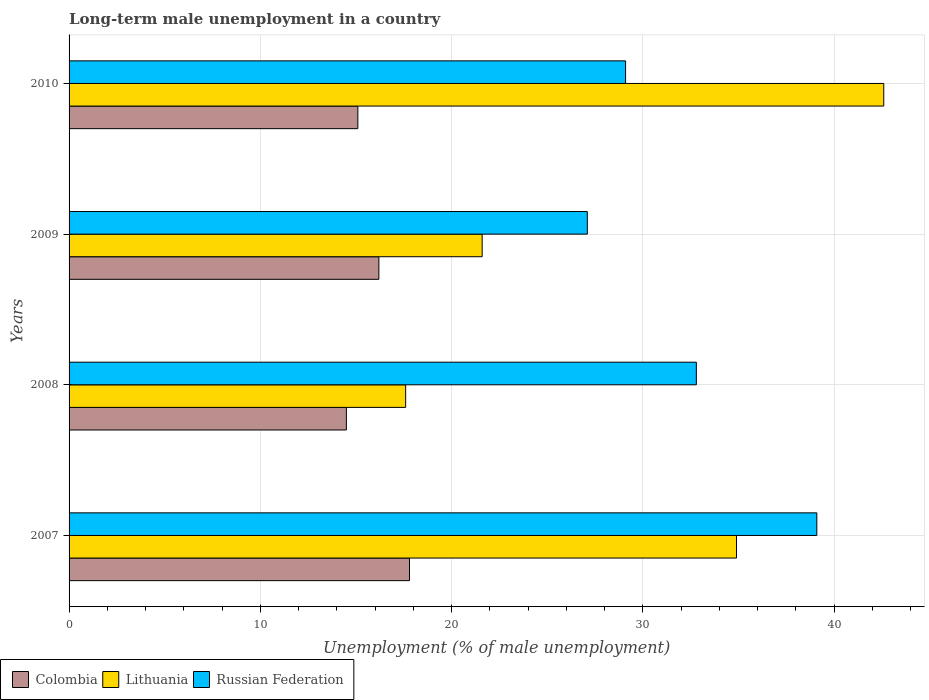How many groups of bars are there?
Offer a terse response. 4. Are the number of bars per tick equal to the number of legend labels?
Your response must be concise. Yes. What is the label of the 1st group of bars from the top?
Your answer should be compact. 2010. In how many cases, is the number of bars for a given year not equal to the number of legend labels?
Your answer should be compact. 0. What is the percentage of long-term unemployed male population in Colombia in 2007?
Offer a terse response. 17.8. Across all years, what is the maximum percentage of long-term unemployed male population in Russian Federation?
Keep it short and to the point. 39.1. What is the total percentage of long-term unemployed male population in Russian Federation in the graph?
Make the answer very short. 128.1. What is the difference between the percentage of long-term unemployed male population in Colombia in 2007 and that in 2010?
Ensure brevity in your answer.  2.7. What is the difference between the percentage of long-term unemployed male population in Lithuania in 2010 and the percentage of long-term unemployed male population in Russian Federation in 2009?
Your answer should be compact. 15.5. What is the average percentage of long-term unemployed male population in Colombia per year?
Ensure brevity in your answer.  15.9. In the year 2008, what is the difference between the percentage of long-term unemployed male population in Colombia and percentage of long-term unemployed male population in Lithuania?
Offer a terse response. -3.1. In how many years, is the percentage of long-term unemployed male population in Colombia greater than 42 %?
Your answer should be compact. 0. What is the ratio of the percentage of long-term unemployed male population in Colombia in 2007 to that in 2008?
Provide a short and direct response. 1.23. Is the percentage of long-term unemployed male population in Lithuania in 2007 less than that in 2010?
Your answer should be very brief. Yes. What is the difference between the highest and the second highest percentage of long-term unemployed male population in Russian Federation?
Your answer should be compact. 6.3. What is the difference between the highest and the lowest percentage of long-term unemployed male population in Lithuania?
Ensure brevity in your answer.  25. What does the 1st bar from the top in 2008 represents?
Give a very brief answer. Russian Federation. What does the 2nd bar from the bottom in 2008 represents?
Ensure brevity in your answer.  Lithuania. Is it the case that in every year, the sum of the percentage of long-term unemployed male population in Russian Federation and percentage of long-term unemployed male population in Lithuania is greater than the percentage of long-term unemployed male population in Colombia?
Ensure brevity in your answer.  Yes. How many bars are there?
Provide a succinct answer. 12. Are all the bars in the graph horizontal?
Give a very brief answer. Yes. How many years are there in the graph?
Your response must be concise. 4. What is the difference between two consecutive major ticks on the X-axis?
Make the answer very short. 10. Does the graph contain any zero values?
Offer a terse response. No. Where does the legend appear in the graph?
Your response must be concise. Bottom left. What is the title of the graph?
Keep it short and to the point. Long-term male unemployment in a country. Does "Fiji" appear as one of the legend labels in the graph?
Your response must be concise. No. What is the label or title of the X-axis?
Your answer should be compact. Unemployment (% of male unemployment). What is the Unemployment (% of male unemployment) in Colombia in 2007?
Make the answer very short. 17.8. What is the Unemployment (% of male unemployment) of Lithuania in 2007?
Provide a succinct answer. 34.9. What is the Unemployment (% of male unemployment) of Russian Federation in 2007?
Keep it short and to the point. 39.1. What is the Unemployment (% of male unemployment) in Lithuania in 2008?
Provide a succinct answer. 17.6. What is the Unemployment (% of male unemployment) of Russian Federation in 2008?
Keep it short and to the point. 32.8. What is the Unemployment (% of male unemployment) in Colombia in 2009?
Make the answer very short. 16.2. What is the Unemployment (% of male unemployment) in Lithuania in 2009?
Keep it short and to the point. 21.6. What is the Unemployment (% of male unemployment) in Russian Federation in 2009?
Provide a succinct answer. 27.1. What is the Unemployment (% of male unemployment) of Colombia in 2010?
Your response must be concise. 15.1. What is the Unemployment (% of male unemployment) of Lithuania in 2010?
Give a very brief answer. 42.6. What is the Unemployment (% of male unemployment) in Russian Federation in 2010?
Keep it short and to the point. 29.1. Across all years, what is the maximum Unemployment (% of male unemployment) in Colombia?
Keep it short and to the point. 17.8. Across all years, what is the maximum Unemployment (% of male unemployment) in Lithuania?
Offer a very short reply. 42.6. Across all years, what is the maximum Unemployment (% of male unemployment) of Russian Federation?
Offer a very short reply. 39.1. Across all years, what is the minimum Unemployment (% of male unemployment) of Lithuania?
Offer a very short reply. 17.6. Across all years, what is the minimum Unemployment (% of male unemployment) in Russian Federation?
Provide a succinct answer. 27.1. What is the total Unemployment (% of male unemployment) in Colombia in the graph?
Offer a very short reply. 63.6. What is the total Unemployment (% of male unemployment) of Lithuania in the graph?
Make the answer very short. 116.7. What is the total Unemployment (% of male unemployment) in Russian Federation in the graph?
Your answer should be compact. 128.1. What is the difference between the Unemployment (% of male unemployment) in Lithuania in 2007 and that in 2008?
Give a very brief answer. 17.3. What is the difference between the Unemployment (% of male unemployment) of Russian Federation in 2007 and that in 2008?
Provide a succinct answer. 6.3. What is the difference between the Unemployment (% of male unemployment) in Colombia in 2007 and that in 2009?
Offer a terse response. 1.6. What is the difference between the Unemployment (% of male unemployment) of Colombia in 2008 and that in 2010?
Ensure brevity in your answer.  -0.6. What is the difference between the Unemployment (% of male unemployment) of Colombia in 2009 and that in 2010?
Offer a very short reply. 1.1. What is the difference between the Unemployment (% of male unemployment) in Russian Federation in 2009 and that in 2010?
Offer a terse response. -2. What is the difference between the Unemployment (% of male unemployment) in Colombia in 2007 and the Unemployment (% of male unemployment) in Russian Federation in 2009?
Offer a terse response. -9.3. What is the difference between the Unemployment (% of male unemployment) in Lithuania in 2007 and the Unemployment (% of male unemployment) in Russian Federation in 2009?
Provide a succinct answer. 7.8. What is the difference between the Unemployment (% of male unemployment) of Colombia in 2007 and the Unemployment (% of male unemployment) of Lithuania in 2010?
Your response must be concise. -24.8. What is the difference between the Unemployment (% of male unemployment) in Colombia in 2007 and the Unemployment (% of male unemployment) in Russian Federation in 2010?
Your answer should be compact. -11.3. What is the difference between the Unemployment (% of male unemployment) in Lithuania in 2007 and the Unemployment (% of male unemployment) in Russian Federation in 2010?
Keep it short and to the point. 5.8. What is the difference between the Unemployment (% of male unemployment) of Colombia in 2008 and the Unemployment (% of male unemployment) of Lithuania in 2009?
Offer a terse response. -7.1. What is the difference between the Unemployment (% of male unemployment) in Colombia in 2008 and the Unemployment (% of male unemployment) in Russian Federation in 2009?
Offer a very short reply. -12.6. What is the difference between the Unemployment (% of male unemployment) in Colombia in 2008 and the Unemployment (% of male unemployment) in Lithuania in 2010?
Your answer should be compact. -28.1. What is the difference between the Unemployment (% of male unemployment) of Colombia in 2008 and the Unemployment (% of male unemployment) of Russian Federation in 2010?
Keep it short and to the point. -14.6. What is the difference between the Unemployment (% of male unemployment) in Lithuania in 2008 and the Unemployment (% of male unemployment) in Russian Federation in 2010?
Your answer should be compact. -11.5. What is the difference between the Unemployment (% of male unemployment) of Colombia in 2009 and the Unemployment (% of male unemployment) of Lithuania in 2010?
Ensure brevity in your answer.  -26.4. What is the difference between the Unemployment (% of male unemployment) of Lithuania in 2009 and the Unemployment (% of male unemployment) of Russian Federation in 2010?
Give a very brief answer. -7.5. What is the average Unemployment (% of male unemployment) in Lithuania per year?
Offer a very short reply. 29.18. What is the average Unemployment (% of male unemployment) in Russian Federation per year?
Ensure brevity in your answer.  32.02. In the year 2007, what is the difference between the Unemployment (% of male unemployment) of Colombia and Unemployment (% of male unemployment) of Lithuania?
Your answer should be compact. -17.1. In the year 2007, what is the difference between the Unemployment (% of male unemployment) in Colombia and Unemployment (% of male unemployment) in Russian Federation?
Your answer should be very brief. -21.3. In the year 2007, what is the difference between the Unemployment (% of male unemployment) of Lithuania and Unemployment (% of male unemployment) of Russian Federation?
Provide a short and direct response. -4.2. In the year 2008, what is the difference between the Unemployment (% of male unemployment) in Colombia and Unemployment (% of male unemployment) in Russian Federation?
Provide a succinct answer. -18.3. In the year 2008, what is the difference between the Unemployment (% of male unemployment) in Lithuania and Unemployment (% of male unemployment) in Russian Federation?
Your answer should be very brief. -15.2. In the year 2009, what is the difference between the Unemployment (% of male unemployment) of Colombia and Unemployment (% of male unemployment) of Lithuania?
Your answer should be very brief. -5.4. In the year 2009, what is the difference between the Unemployment (% of male unemployment) in Colombia and Unemployment (% of male unemployment) in Russian Federation?
Make the answer very short. -10.9. In the year 2009, what is the difference between the Unemployment (% of male unemployment) of Lithuania and Unemployment (% of male unemployment) of Russian Federation?
Ensure brevity in your answer.  -5.5. In the year 2010, what is the difference between the Unemployment (% of male unemployment) in Colombia and Unemployment (% of male unemployment) in Lithuania?
Your answer should be compact. -27.5. What is the ratio of the Unemployment (% of male unemployment) of Colombia in 2007 to that in 2008?
Ensure brevity in your answer.  1.23. What is the ratio of the Unemployment (% of male unemployment) in Lithuania in 2007 to that in 2008?
Your response must be concise. 1.98. What is the ratio of the Unemployment (% of male unemployment) in Russian Federation in 2007 to that in 2008?
Provide a succinct answer. 1.19. What is the ratio of the Unemployment (% of male unemployment) of Colombia in 2007 to that in 2009?
Give a very brief answer. 1.1. What is the ratio of the Unemployment (% of male unemployment) in Lithuania in 2007 to that in 2009?
Offer a very short reply. 1.62. What is the ratio of the Unemployment (% of male unemployment) in Russian Federation in 2007 to that in 2009?
Provide a succinct answer. 1.44. What is the ratio of the Unemployment (% of male unemployment) of Colombia in 2007 to that in 2010?
Provide a succinct answer. 1.18. What is the ratio of the Unemployment (% of male unemployment) of Lithuania in 2007 to that in 2010?
Make the answer very short. 0.82. What is the ratio of the Unemployment (% of male unemployment) of Russian Federation in 2007 to that in 2010?
Keep it short and to the point. 1.34. What is the ratio of the Unemployment (% of male unemployment) in Colombia in 2008 to that in 2009?
Make the answer very short. 0.9. What is the ratio of the Unemployment (% of male unemployment) in Lithuania in 2008 to that in 2009?
Give a very brief answer. 0.81. What is the ratio of the Unemployment (% of male unemployment) in Russian Federation in 2008 to that in 2009?
Provide a succinct answer. 1.21. What is the ratio of the Unemployment (% of male unemployment) in Colombia in 2008 to that in 2010?
Offer a terse response. 0.96. What is the ratio of the Unemployment (% of male unemployment) of Lithuania in 2008 to that in 2010?
Give a very brief answer. 0.41. What is the ratio of the Unemployment (% of male unemployment) in Russian Federation in 2008 to that in 2010?
Ensure brevity in your answer.  1.13. What is the ratio of the Unemployment (% of male unemployment) in Colombia in 2009 to that in 2010?
Ensure brevity in your answer.  1.07. What is the ratio of the Unemployment (% of male unemployment) of Lithuania in 2009 to that in 2010?
Offer a terse response. 0.51. What is the ratio of the Unemployment (% of male unemployment) in Russian Federation in 2009 to that in 2010?
Ensure brevity in your answer.  0.93. What is the difference between the highest and the second highest Unemployment (% of male unemployment) of Colombia?
Ensure brevity in your answer.  1.6. What is the difference between the highest and the second highest Unemployment (% of male unemployment) in Lithuania?
Keep it short and to the point. 7.7. What is the difference between the highest and the second highest Unemployment (% of male unemployment) in Russian Federation?
Keep it short and to the point. 6.3. What is the difference between the highest and the lowest Unemployment (% of male unemployment) in Lithuania?
Offer a very short reply. 25. 